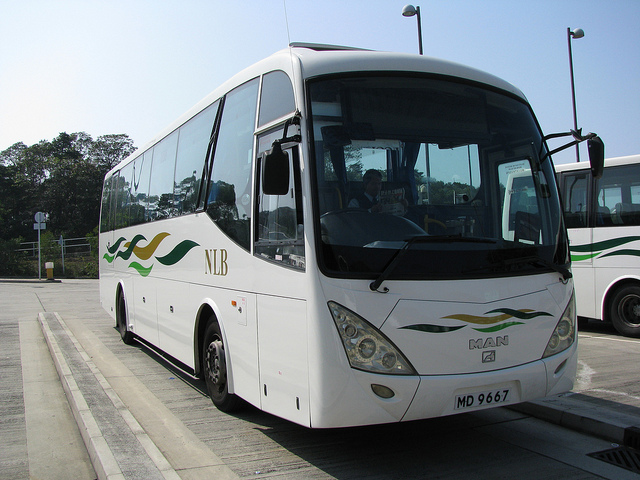Read and extract the text from this image. NLB MAN 9667 MD 